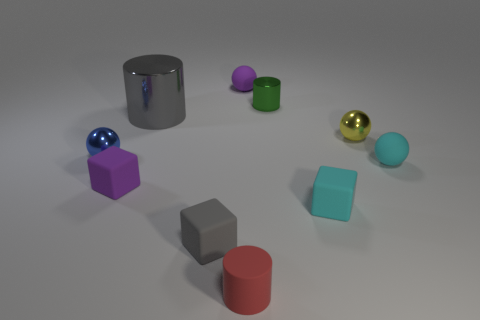Subtract all cylinders. How many objects are left? 7 Add 3 large rubber cubes. How many large rubber cubes exist? 3 Subtract 0 brown blocks. How many objects are left? 10 Subtract all small yellow spheres. Subtract all blue shiny things. How many objects are left? 8 Add 6 cyan things. How many cyan things are left? 8 